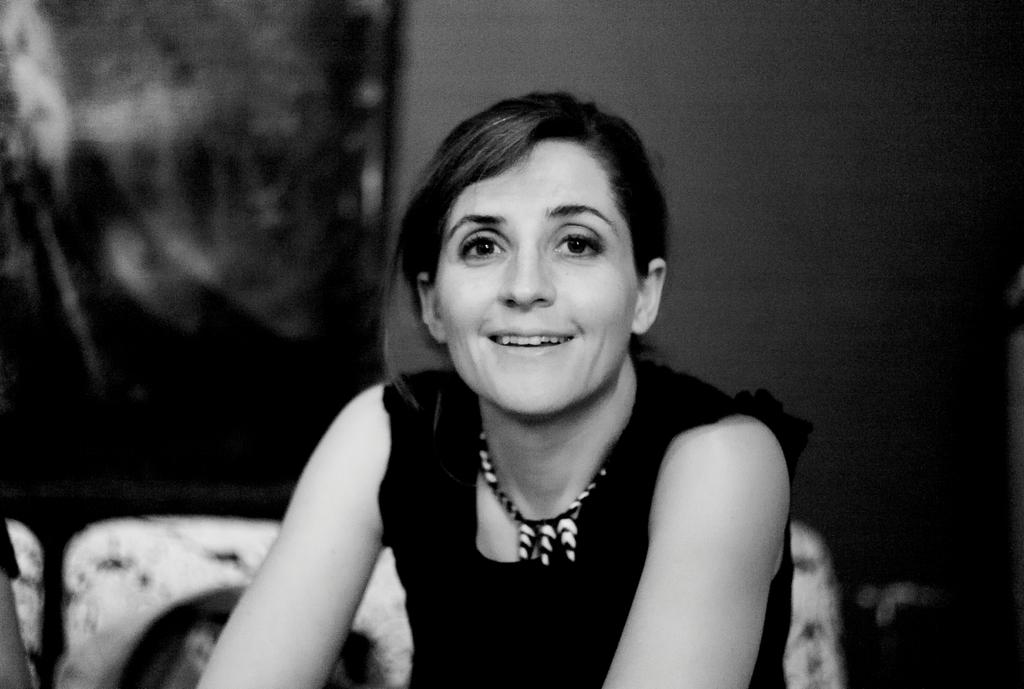What is the color scheme of the image? The image is black and white. Can you describe the main subject in the image? There is a person in the image. What can be observed about the background of the image? The background of the image is blurred. Can you tell me how many monkeys are visible in the image? There are no monkeys present in the image. What type of ring is the goose wearing on its foot in the image? There is no goose or ring present in the image. 